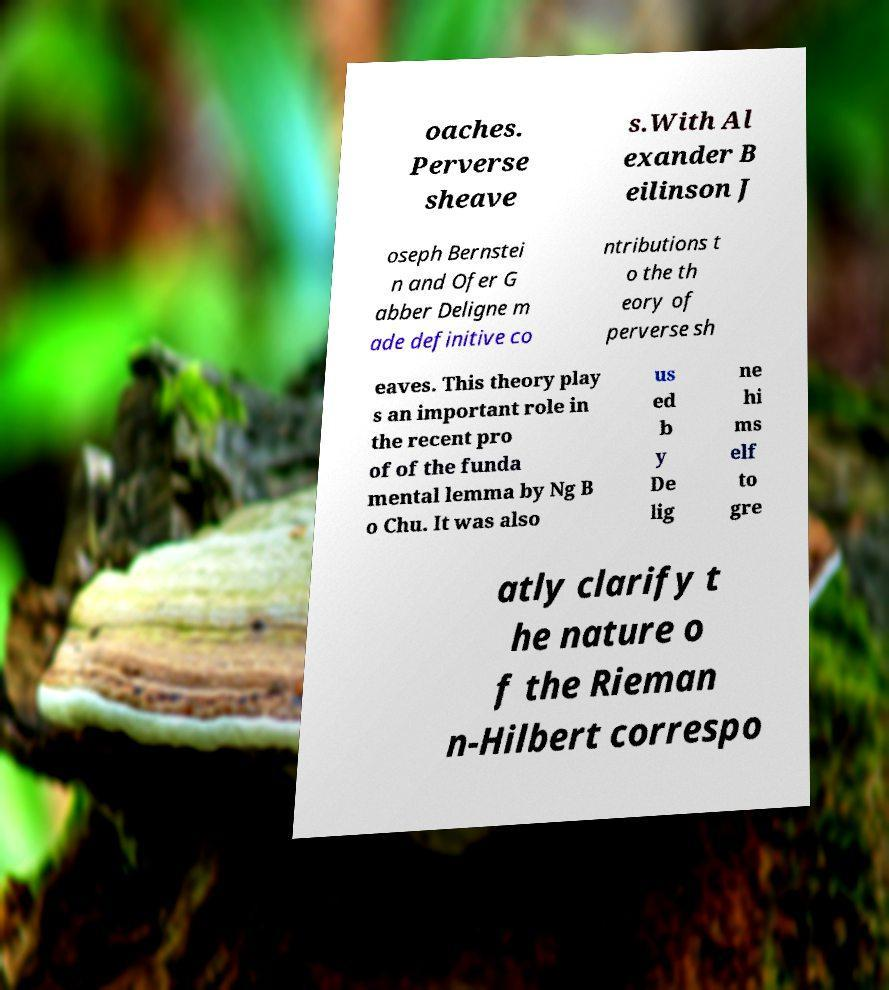Could you extract and type out the text from this image? oaches. Perverse sheave s.With Al exander B eilinson J oseph Bernstei n and Ofer G abber Deligne m ade definitive co ntributions t o the th eory of perverse sh eaves. This theory play s an important role in the recent pro of of the funda mental lemma by Ng B o Chu. It was also us ed b y De lig ne hi ms elf to gre atly clarify t he nature o f the Rieman n-Hilbert correspo 